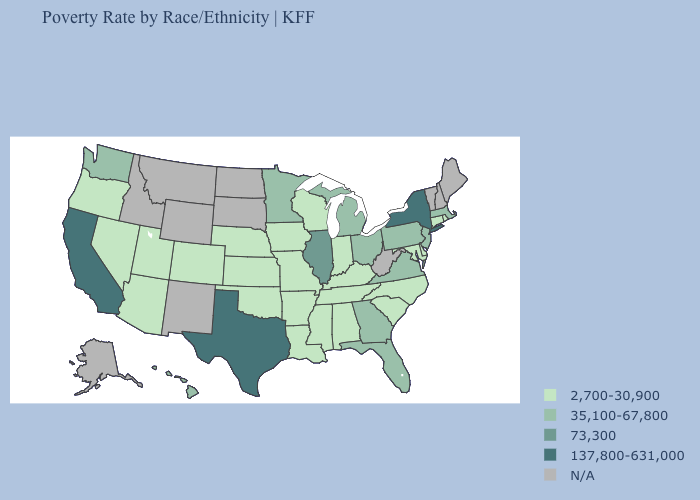Name the states that have a value in the range 137,800-631,000?
Keep it brief. California, New York, Texas. What is the highest value in the West ?
Answer briefly. 137,800-631,000. What is the lowest value in the USA?
Quick response, please. 2,700-30,900. Does Virginia have the lowest value in the USA?
Answer briefly. No. What is the value of Alaska?
Write a very short answer. N/A. Which states have the lowest value in the MidWest?
Give a very brief answer. Indiana, Iowa, Kansas, Missouri, Nebraska, Wisconsin. How many symbols are there in the legend?
Answer briefly. 5. Name the states that have a value in the range 73,300?
Answer briefly. Illinois. How many symbols are there in the legend?
Short answer required. 5. Name the states that have a value in the range 35,100-67,800?
Answer briefly. Florida, Georgia, Hawaii, Massachusetts, Michigan, Minnesota, New Jersey, Ohio, Pennsylvania, Virginia, Washington. Does the first symbol in the legend represent the smallest category?
Concise answer only. Yes. What is the value of New York?
Concise answer only. 137,800-631,000. Name the states that have a value in the range 35,100-67,800?
Concise answer only. Florida, Georgia, Hawaii, Massachusetts, Michigan, Minnesota, New Jersey, Ohio, Pennsylvania, Virginia, Washington. What is the highest value in the USA?
Quick response, please. 137,800-631,000. What is the value of Idaho?
Write a very short answer. N/A. 